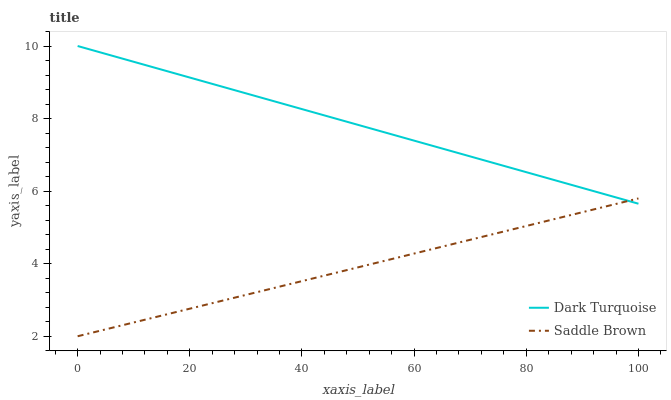Does Saddle Brown have the minimum area under the curve?
Answer yes or no. Yes. Does Dark Turquoise have the maximum area under the curve?
Answer yes or no. Yes. Does Saddle Brown have the maximum area under the curve?
Answer yes or no. No. Is Saddle Brown the smoothest?
Answer yes or no. Yes. Is Dark Turquoise the roughest?
Answer yes or no. Yes. Is Saddle Brown the roughest?
Answer yes or no. No. Does Saddle Brown have the lowest value?
Answer yes or no. Yes. Does Dark Turquoise have the highest value?
Answer yes or no. Yes. Does Saddle Brown have the highest value?
Answer yes or no. No. Does Dark Turquoise intersect Saddle Brown?
Answer yes or no. Yes. Is Dark Turquoise less than Saddle Brown?
Answer yes or no. No. Is Dark Turquoise greater than Saddle Brown?
Answer yes or no. No. 